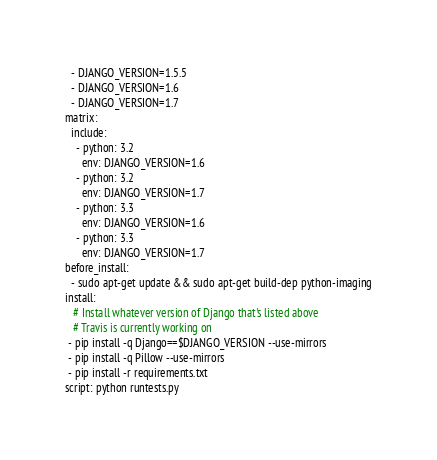<code> <loc_0><loc_0><loc_500><loc_500><_YAML_>  - DJANGO_VERSION=1.5.5
  - DJANGO_VERSION=1.6
  - DJANGO_VERSION=1.7
matrix:
  include:
    - python: 3.2
      env: DJANGO_VERSION=1.6
    - python: 3.2
      env: DJANGO_VERSION=1.7
    - python: 3.3
      env: DJANGO_VERSION=1.6
    - python: 3.3
      env: DJANGO_VERSION=1.7
before_install:
  - sudo apt-get update && sudo apt-get build-dep python-imaging
install:
   # Install whatever version of Django that's listed above
   # Travis is currently working on
 - pip install -q Django==$DJANGO_VERSION --use-mirrors
 - pip install -q Pillow --use-mirrors
 - pip install -r requirements.txt
script: python runtests.py
</code> 